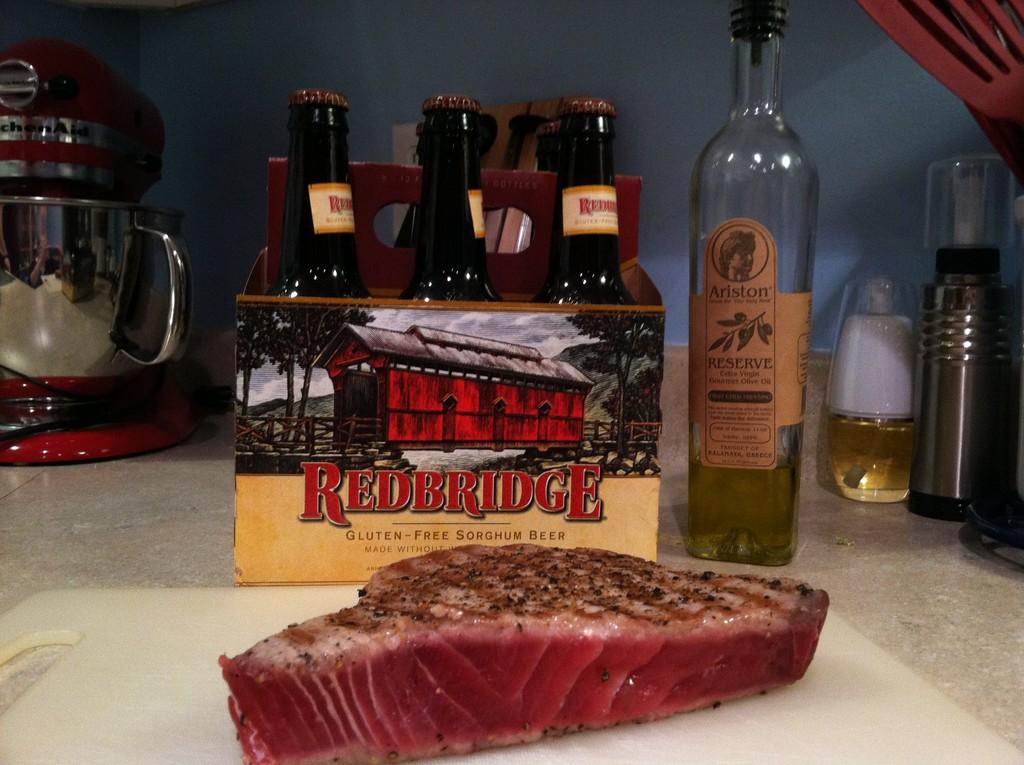Is the beer gluten free?
Give a very brief answer. Yes. 